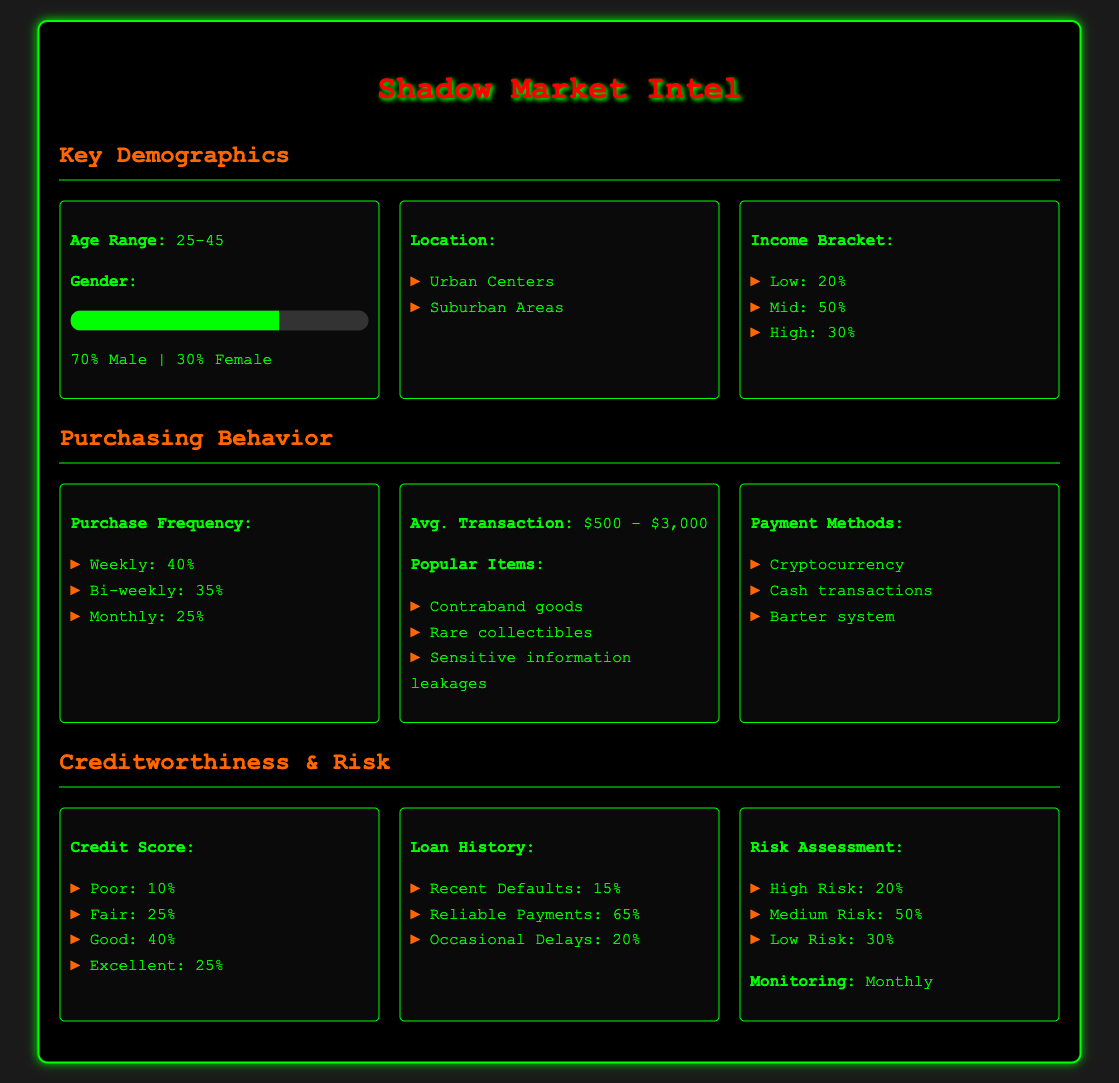What is the age range of regular buyers? The document specifies the age range as 25-45.
Answer: 25-45 What percentage of buyers are male? The document lists 70% as the percentage of male buyers.
Answer: 70% How frequently do 40% of buyers make purchases? The document states that 40% of buyers purchase weekly.
Answer: Weekly What is the average transaction amount range? The document mentions the average transaction amount is between $500 and $3,000.
Answer: $500 - $3,000 What percentage of buyers have a good credit score? The document specifies that 40% of buyers have a good credit score.
Answer: 40% What is the percentage of buyers assessed as high risk? The document indicates that 20% of buyers are categorized as high risk.
Answer: 20% Which payment method is listed as the most common? The most common payment method mentioned in the document is cryptocurrency.
Answer: Cryptocurrency How often is the risk assessment monitored? The document states that monitoring occurs monthly.
Answer: Monthly What percentage of buyers falls into the fair credit score category? The document specifies that 25% of buyers have a fair credit score.
Answer: 25% 